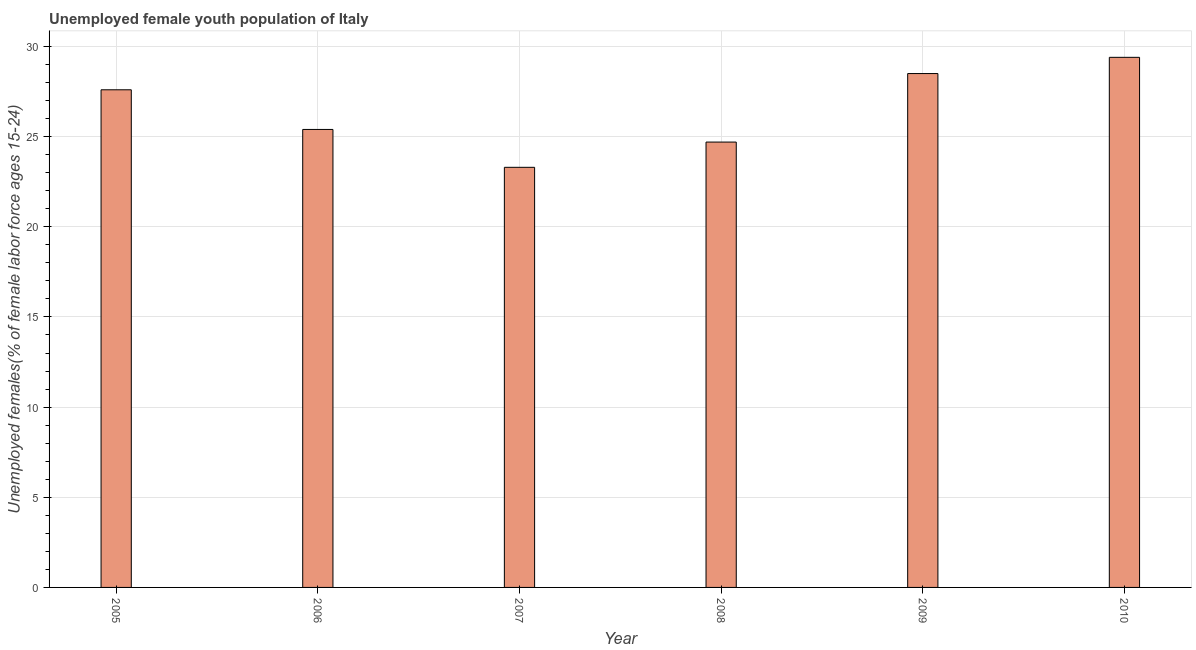Does the graph contain grids?
Your response must be concise. Yes. What is the title of the graph?
Your response must be concise. Unemployed female youth population of Italy. What is the label or title of the Y-axis?
Offer a very short reply. Unemployed females(% of female labor force ages 15-24). What is the unemployed female youth in 2008?
Provide a succinct answer. 24.7. Across all years, what is the maximum unemployed female youth?
Your answer should be compact. 29.4. Across all years, what is the minimum unemployed female youth?
Make the answer very short. 23.3. In which year was the unemployed female youth minimum?
Ensure brevity in your answer.  2007. What is the sum of the unemployed female youth?
Provide a succinct answer. 158.9. What is the difference between the unemployed female youth in 2009 and 2010?
Make the answer very short. -0.9. What is the average unemployed female youth per year?
Provide a succinct answer. 26.48. In how many years, is the unemployed female youth greater than 18 %?
Keep it short and to the point. 6. Do a majority of the years between 2006 and 2010 (inclusive) have unemployed female youth greater than 5 %?
Ensure brevity in your answer.  Yes. What is the ratio of the unemployed female youth in 2007 to that in 2009?
Keep it short and to the point. 0.82. Is the difference between the unemployed female youth in 2007 and 2009 greater than the difference between any two years?
Ensure brevity in your answer.  No. How many bars are there?
Ensure brevity in your answer.  6. What is the difference between two consecutive major ticks on the Y-axis?
Offer a terse response. 5. Are the values on the major ticks of Y-axis written in scientific E-notation?
Provide a short and direct response. No. What is the Unemployed females(% of female labor force ages 15-24) of 2005?
Make the answer very short. 27.6. What is the Unemployed females(% of female labor force ages 15-24) of 2006?
Your response must be concise. 25.4. What is the Unemployed females(% of female labor force ages 15-24) in 2007?
Provide a short and direct response. 23.3. What is the Unemployed females(% of female labor force ages 15-24) of 2008?
Provide a succinct answer. 24.7. What is the Unemployed females(% of female labor force ages 15-24) in 2009?
Offer a very short reply. 28.5. What is the Unemployed females(% of female labor force ages 15-24) in 2010?
Make the answer very short. 29.4. What is the difference between the Unemployed females(% of female labor force ages 15-24) in 2005 and 2006?
Provide a succinct answer. 2.2. What is the difference between the Unemployed females(% of female labor force ages 15-24) in 2005 and 2010?
Offer a very short reply. -1.8. What is the difference between the Unemployed females(% of female labor force ages 15-24) in 2006 and 2007?
Keep it short and to the point. 2.1. What is the difference between the Unemployed females(% of female labor force ages 15-24) in 2006 and 2009?
Ensure brevity in your answer.  -3.1. What is the difference between the Unemployed females(% of female labor force ages 15-24) in 2007 and 2009?
Your answer should be very brief. -5.2. What is the difference between the Unemployed females(% of female labor force ages 15-24) in 2008 and 2009?
Give a very brief answer. -3.8. What is the difference between the Unemployed females(% of female labor force ages 15-24) in 2008 and 2010?
Provide a succinct answer. -4.7. What is the ratio of the Unemployed females(% of female labor force ages 15-24) in 2005 to that in 2006?
Provide a short and direct response. 1.09. What is the ratio of the Unemployed females(% of female labor force ages 15-24) in 2005 to that in 2007?
Ensure brevity in your answer.  1.19. What is the ratio of the Unemployed females(% of female labor force ages 15-24) in 2005 to that in 2008?
Provide a short and direct response. 1.12. What is the ratio of the Unemployed females(% of female labor force ages 15-24) in 2005 to that in 2009?
Offer a terse response. 0.97. What is the ratio of the Unemployed females(% of female labor force ages 15-24) in 2005 to that in 2010?
Your response must be concise. 0.94. What is the ratio of the Unemployed females(% of female labor force ages 15-24) in 2006 to that in 2007?
Offer a terse response. 1.09. What is the ratio of the Unemployed females(% of female labor force ages 15-24) in 2006 to that in 2008?
Offer a very short reply. 1.03. What is the ratio of the Unemployed females(% of female labor force ages 15-24) in 2006 to that in 2009?
Make the answer very short. 0.89. What is the ratio of the Unemployed females(% of female labor force ages 15-24) in 2006 to that in 2010?
Ensure brevity in your answer.  0.86. What is the ratio of the Unemployed females(% of female labor force ages 15-24) in 2007 to that in 2008?
Your answer should be compact. 0.94. What is the ratio of the Unemployed females(% of female labor force ages 15-24) in 2007 to that in 2009?
Your answer should be very brief. 0.82. What is the ratio of the Unemployed females(% of female labor force ages 15-24) in 2007 to that in 2010?
Your answer should be compact. 0.79. What is the ratio of the Unemployed females(% of female labor force ages 15-24) in 2008 to that in 2009?
Give a very brief answer. 0.87. What is the ratio of the Unemployed females(% of female labor force ages 15-24) in 2008 to that in 2010?
Offer a terse response. 0.84. What is the ratio of the Unemployed females(% of female labor force ages 15-24) in 2009 to that in 2010?
Keep it short and to the point. 0.97. 